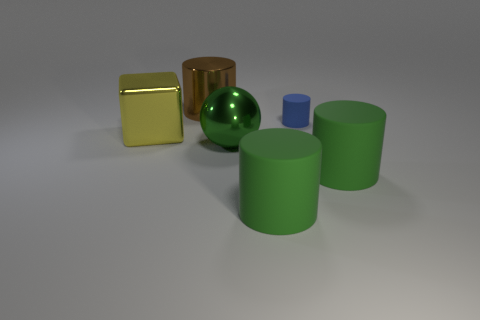Is there anything else that is the same size as the blue matte thing?
Your response must be concise. No. There is a big cylinder left of the shiny thing to the right of the brown object; what is its color?
Give a very brief answer. Brown. Are there fewer big cylinders to the left of the metal ball than objects that are behind the big yellow shiny cube?
Provide a succinct answer. Yes. Do the blue rubber cylinder and the brown metallic cylinder have the same size?
Provide a short and direct response. No. What shape is the object that is both in front of the big brown cylinder and behind the big block?
Your response must be concise. Cylinder. How many large brown things have the same material as the blue cylinder?
Your response must be concise. 0. There is a big shiny object that is in front of the block; how many blocks are on the right side of it?
Your answer should be compact. 0. What is the shape of the small blue rubber object that is to the right of the large shiny block that is to the left of the big metal thing to the right of the brown metallic object?
Your answer should be compact. Cylinder. How many things are blue rubber things or small brown rubber things?
Offer a terse response. 1. What is the color of the sphere that is the same size as the cube?
Your answer should be very brief. Green. 